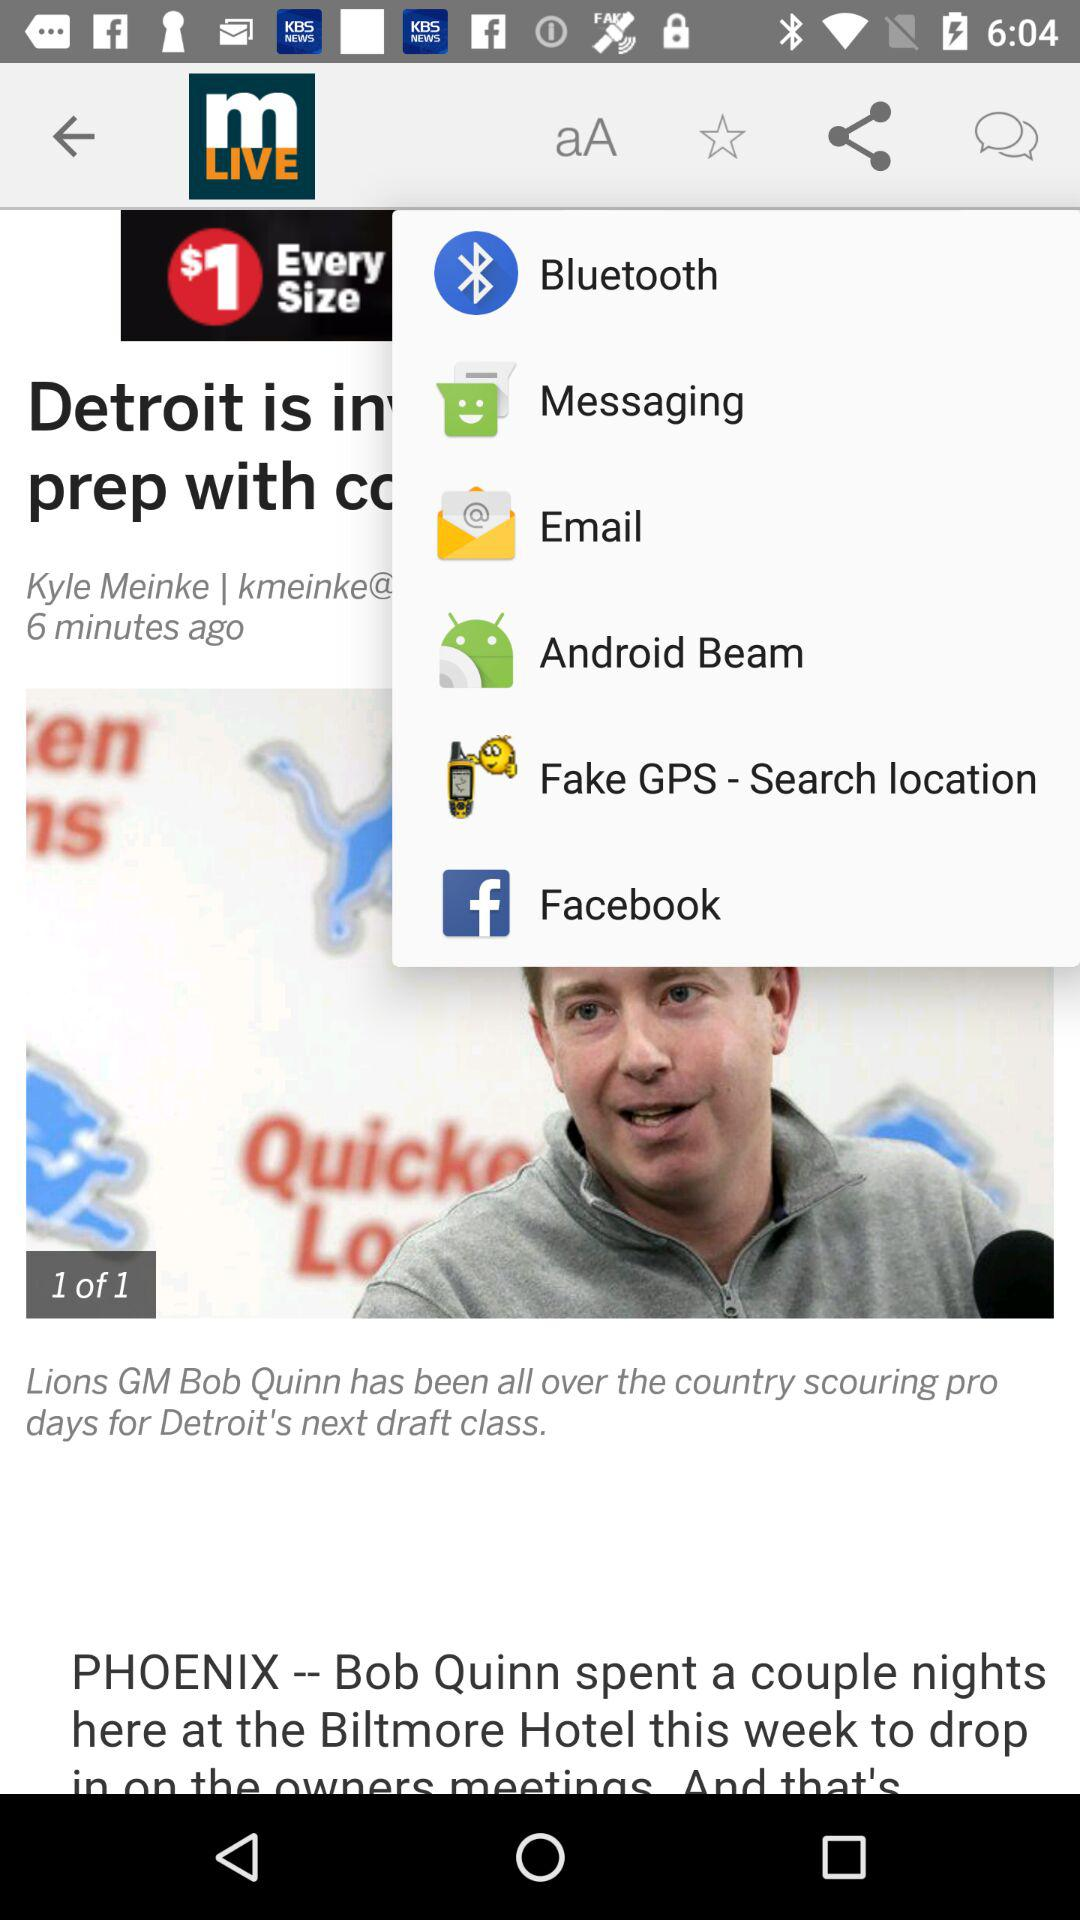On which image am I now? You are now on the first image. 